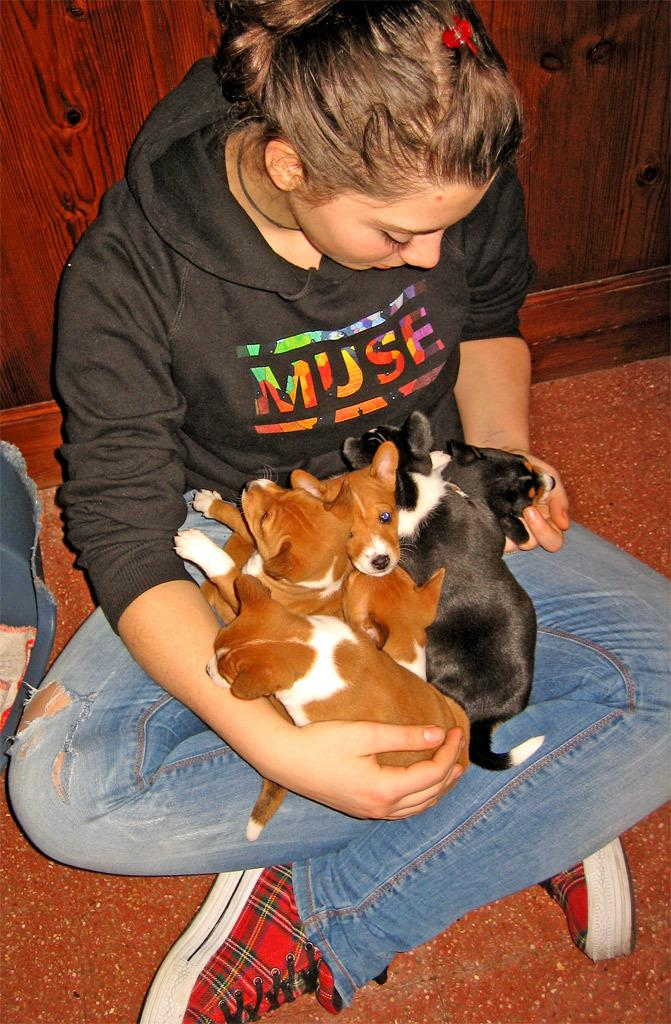Who is present in the image? There is a woman in the image. What is the woman doing in the image? The woman is sitting on the floor and holding some dogs. What can be seen beside the woman? There is an object beside the woman. What is visible in the background of the image? There is a wall visible in the background of the image. What type of pear is being used as a leash for the dogs in the image? There is no pear present in the image, nor are the dogs being held by a pear. 